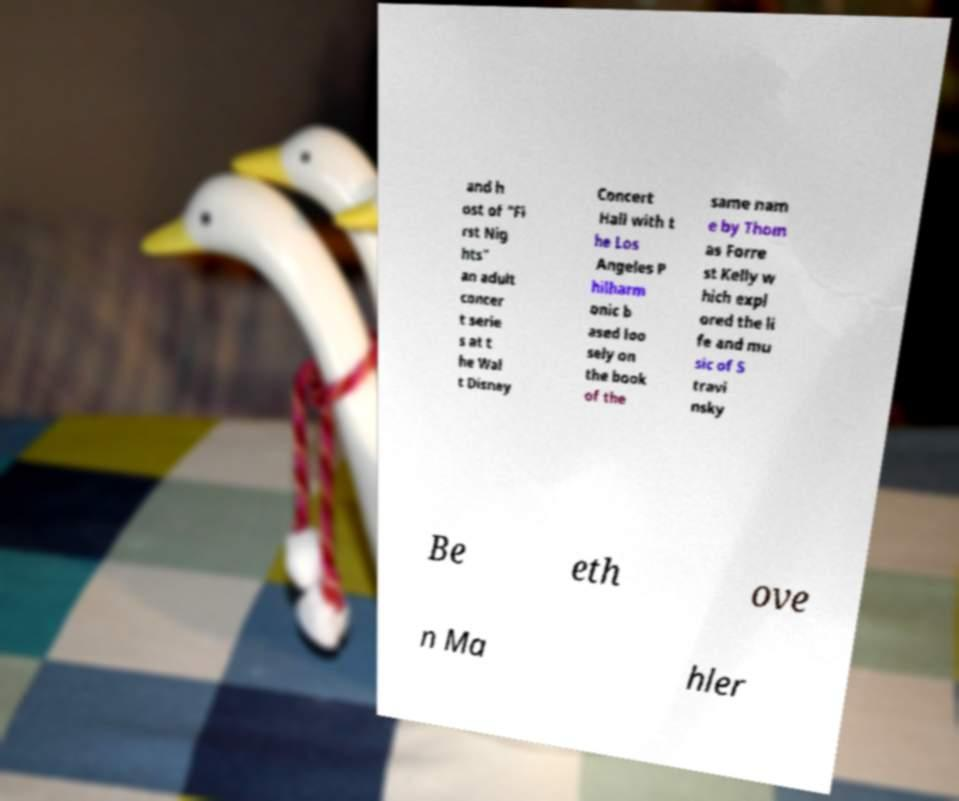Please identify and transcribe the text found in this image. and h ost of "Fi rst Nig hts" an adult concer t serie s at t he Wal t Disney Concert Hall with t he Los Angeles P hilharm onic b ased loo sely on the book of the same nam e by Thom as Forre st Kelly w hich expl ored the li fe and mu sic of S travi nsky Be eth ove n Ma hler 